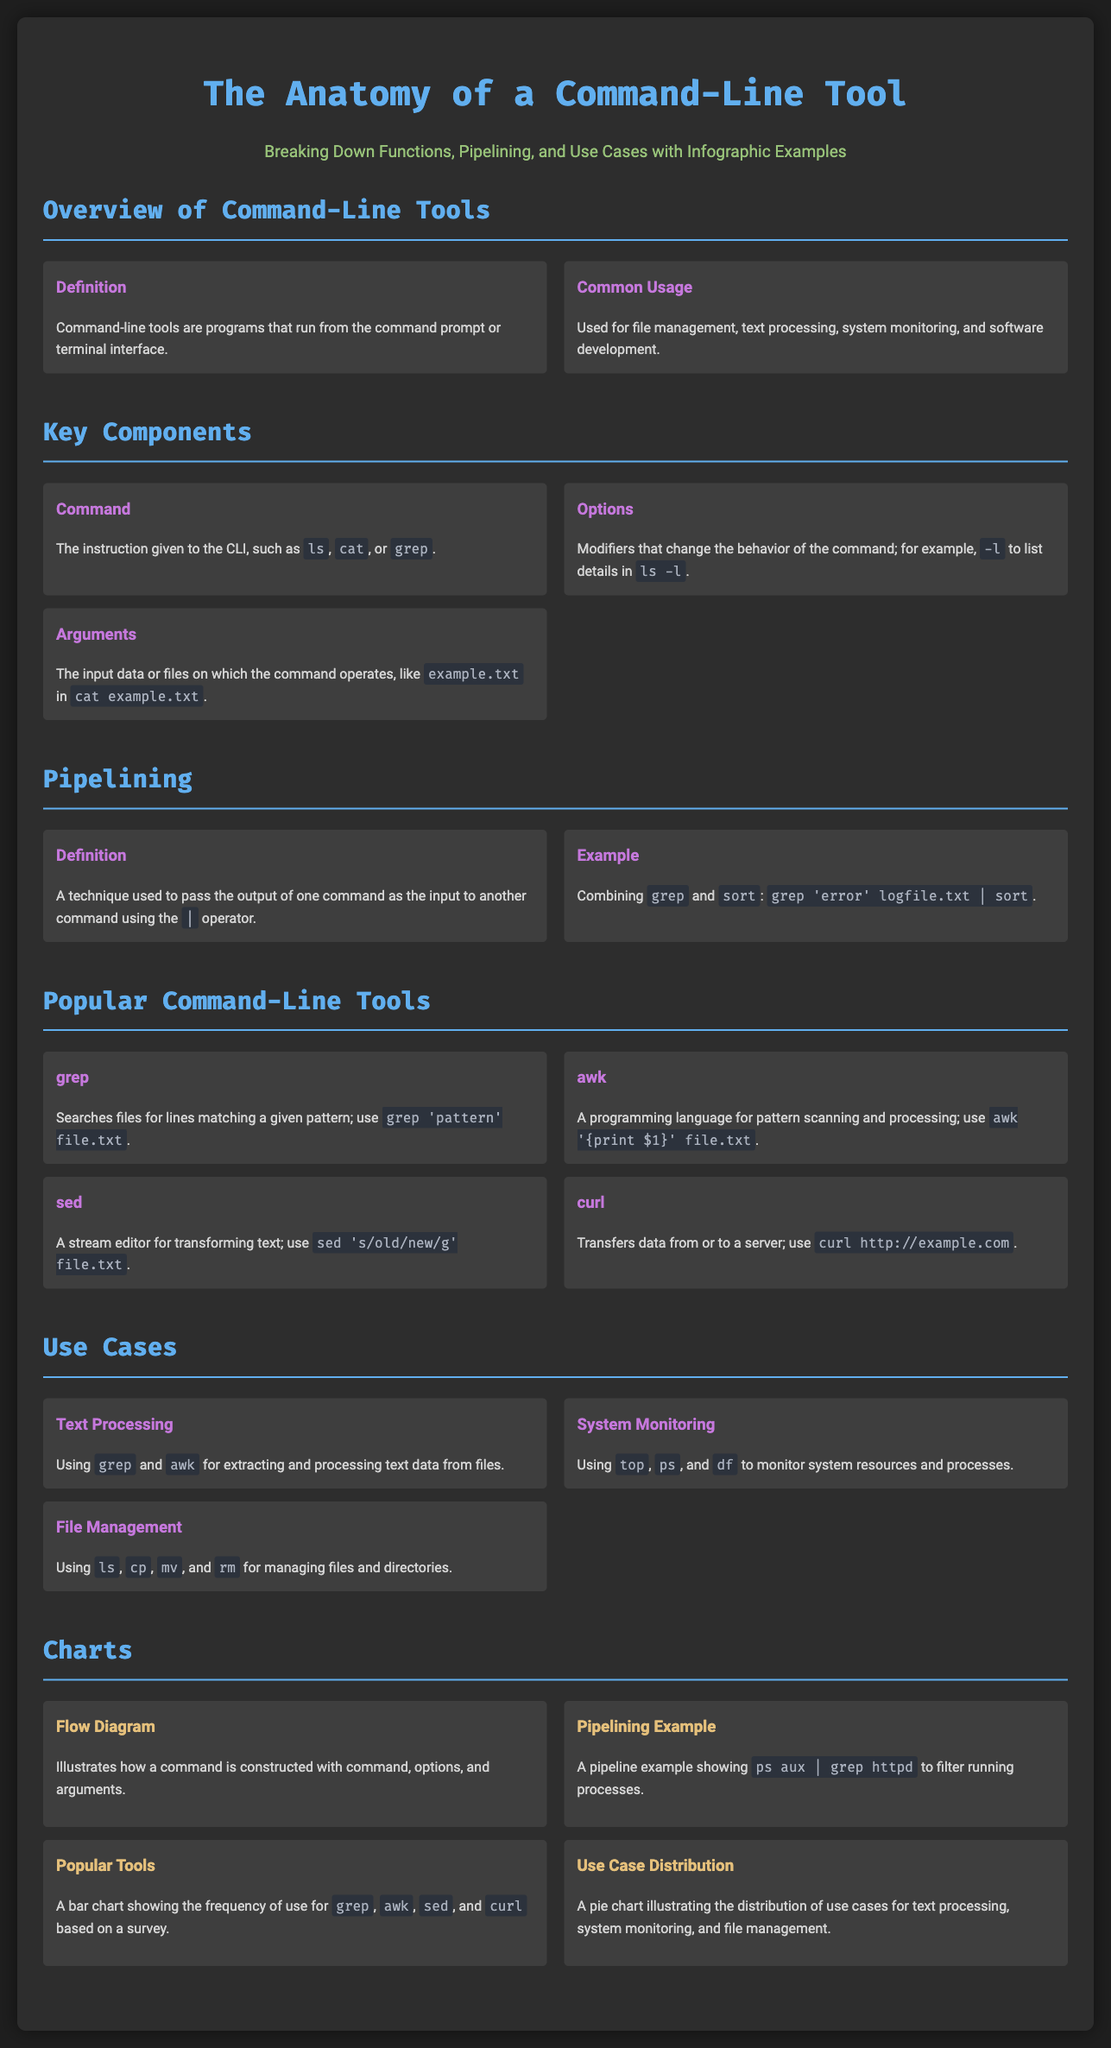What is the title of the infographic? The title is prominently displayed at the top of the document.
Answer: The Anatomy of a Command-Line Tool What is the function of the command-line tool 'grep'? The document describes its function in the section on popular command-line tools.
Answer: Searches files for lines matching a given pattern Which command is used for file management according to the use cases? The use cases section lists several commands used for file management.
Answer: ls, cp, mv, rm What is illustrated in the flow diagram? The charts section specifies what the flow diagram represents.
Answer: How a command is constructed What is the most common use case for command-line tools according to the document? The content on use cases provides insight into different applications of command-line tools.
Answer: Text Processing Which command displays running processes according to the use cases? The document mentions specific commands used for system monitoring in the use cases section.
Answer: ps How many popular command-line tools are listed? The popular command-line tools section lists the number of tools explicitly mentioned.
Answer: Four What type of chart illustrates the distribution of use cases? The charts section describes the type of chart used for the distribution of use cases.
Answer: Pie chart 